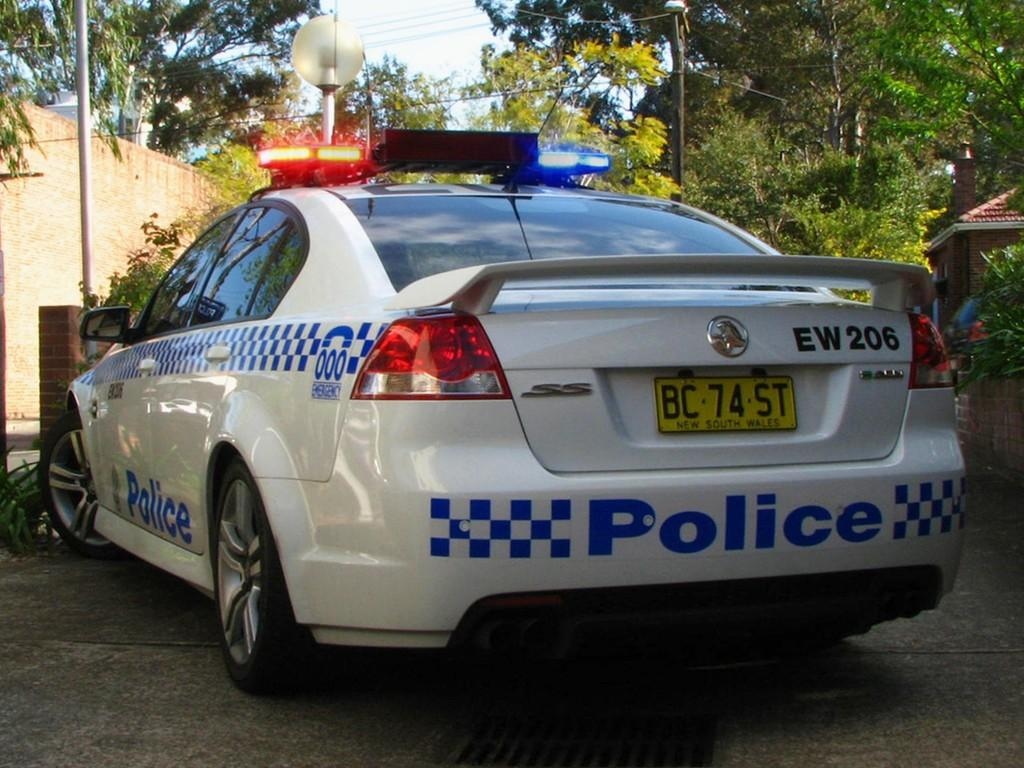What type of vehicle is present in the image? There is a police car in the image. What type of natural elements can be seen in the image? Trees are visible in the image. What type of infrastructure is present in the image? Light poles and electric wires are present in the image. What type of man-made surface is visible in the image? There is a road in the image. What part of the natural environment is visible in the image? The sky is visible in the image. What type of structure might be present in the image? It appears that there is a building in the image. What type of cabbage is being transported in the basket in the image? There is no cabbage or basket present in the image. 